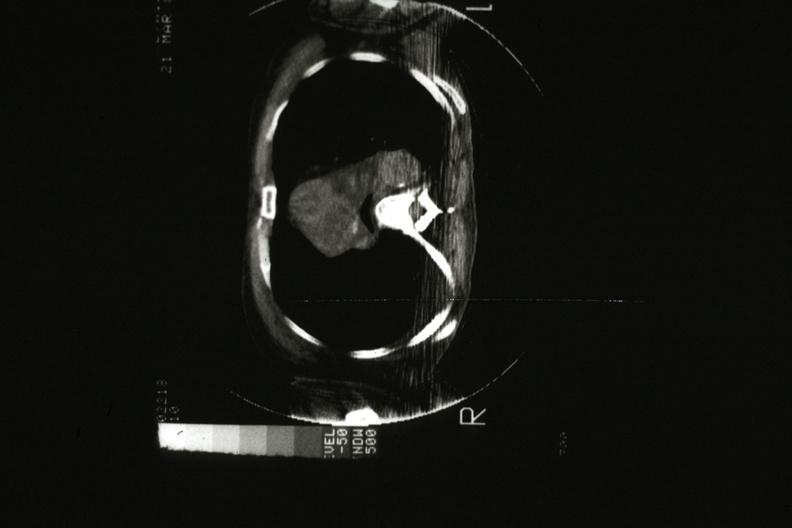s thymus present?
Answer the question using a single word or phrase. Yes 